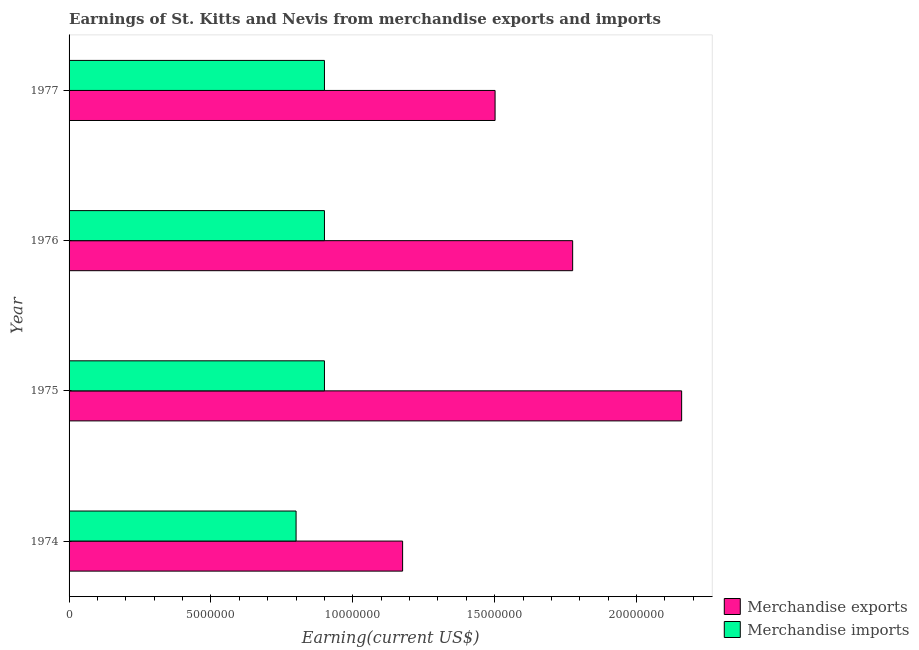How many different coloured bars are there?
Make the answer very short. 2. Are the number of bars per tick equal to the number of legend labels?
Keep it short and to the point. Yes. Are the number of bars on each tick of the Y-axis equal?
Keep it short and to the point. Yes. How many bars are there on the 1st tick from the bottom?
Provide a short and direct response. 2. In how many cases, is the number of bars for a given year not equal to the number of legend labels?
Provide a succinct answer. 0. What is the earnings from merchandise imports in 1975?
Provide a short and direct response. 9.00e+06. Across all years, what is the maximum earnings from merchandise imports?
Make the answer very short. 9.00e+06. Across all years, what is the minimum earnings from merchandise imports?
Your response must be concise. 8.00e+06. In which year was the earnings from merchandise exports maximum?
Provide a succinct answer. 1975. In which year was the earnings from merchandise imports minimum?
Provide a succinct answer. 1974. What is the total earnings from merchandise exports in the graph?
Your answer should be compact. 6.61e+07. What is the difference between the earnings from merchandise imports in 1975 and that in 1977?
Your answer should be compact. 0. What is the difference between the earnings from merchandise imports in 1975 and the earnings from merchandise exports in 1974?
Provide a short and direct response. -2.75e+06. What is the average earnings from merchandise imports per year?
Offer a very short reply. 8.75e+06. In the year 1974, what is the difference between the earnings from merchandise exports and earnings from merchandise imports?
Give a very brief answer. 3.75e+06. What is the ratio of the earnings from merchandise exports in 1974 to that in 1976?
Your answer should be compact. 0.66. Is the earnings from merchandise exports in 1974 less than that in 1976?
Make the answer very short. Yes. Is the difference between the earnings from merchandise exports in 1974 and 1975 greater than the difference between the earnings from merchandise imports in 1974 and 1975?
Your response must be concise. No. What is the difference between the highest and the second highest earnings from merchandise exports?
Provide a succinct answer. 3.84e+06. What is the difference between the highest and the lowest earnings from merchandise exports?
Your response must be concise. 9.83e+06. What does the 1st bar from the bottom in 1975 represents?
Your answer should be very brief. Merchandise exports. How many bars are there?
Ensure brevity in your answer.  8. Are the values on the major ticks of X-axis written in scientific E-notation?
Ensure brevity in your answer.  No. Does the graph contain grids?
Give a very brief answer. No. What is the title of the graph?
Ensure brevity in your answer.  Earnings of St. Kitts and Nevis from merchandise exports and imports. What is the label or title of the X-axis?
Offer a very short reply. Earning(current US$). What is the Earning(current US$) in Merchandise exports in 1974?
Your response must be concise. 1.18e+07. What is the Earning(current US$) of Merchandise exports in 1975?
Provide a short and direct response. 2.16e+07. What is the Earning(current US$) in Merchandise imports in 1975?
Make the answer very short. 9.00e+06. What is the Earning(current US$) in Merchandise exports in 1976?
Provide a short and direct response. 1.77e+07. What is the Earning(current US$) in Merchandise imports in 1976?
Your answer should be compact. 9.00e+06. What is the Earning(current US$) of Merchandise exports in 1977?
Your answer should be compact. 1.50e+07. What is the Earning(current US$) of Merchandise imports in 1977?
Your answer should be very brief. 9.00e+06. Across all years, what is the maximum Earning(current US$) of Merchandise exports?
Keep it short and to the point. 2.16e+07. Across all years, what is the maximum Earning(current US$) of Merchandise imports?
Your response must be concise. 9.00e+06. Across all years, what is the minimum Earning(current US$) in Merchandise exports?
Offer a terse response. 1.18e+07. What is the total Earning(current US$) of Merchandise exports in the graph?
Your answer should be very brief. 6.61e+07. What is the total Earning(current US$) in Merchandise imports in the graph?
Provide a short and direct response. 3.50e+07. What is the difference between the Earning(current US$) of Merchandise exports in 1974 and that in 1975?
Provide a short and direct response. -9.83e+06. What is the difference between the Earning(current US$) in Merchandise exports in 1974 and that in 1976?
Your answer should be compact. -5.99e+06. What is the difference between the Earning(current US$) in Merchandise exports in 1974 and that in 1977?
Make the answer very short. -3.26e+06. What is the difference between the Earning(current US$) of Merchandise imports in 1974 and that in 1977?
Offer a very short reply. -1.00e+06. What is the difference between the Earning(current US$) of Merchandise exports in 1975 and that in 1976?
Your answer should be very brief. 3.84e+06. What is the difference between the Earning(current US$) of Merchandise exports in 1975 and that in 1977?
Your response must be concise. 6.57e+06. What is the difference between the Earning(current US$) in Merchandise imports in 1975 and that in 1977?
Your answer should be compact. 0. What is the difference between the Earning(current US$) of Merchandise exports in 1976 and that in 1977?
Your answer should be compact. 2.73e+06. What is the difference between the Earning(current US$) in Merchandise exports in 1974 and the Earning(current US$) in Merchandise imports in 1975?
Your answer should be compact. 2.75e+06. What is the difference between the Earning(current US$) in Merchandise exports in 1974 and the Earning(current US$) in Merchandise imports in 1976?
Your answer should be very brief. 2.75e+06. What is the difference between the Earning(current US$) in Merchandise exports in 1974 and the Earning(current US$) in Merchandise imports in 1977?
Provide a succinct answer. 2.75e+06. What is the difference between the Earning(current US$) in Merchandise exports in 1975 and the Earning(current US$) in Merchandise imports in 1976?
Offer a terse response. 1.26e+07. What is the difference between the Earning(current US$) in Merchandise exports in 1975 and the Earning(current US$) in Merchandise imports in 1977?
Keep it short and to the point. 1.26e+07. What is the difference between the Earning(current US$) of Merchandise exports in 1976 and the Earning(current US$) of Merchandise imports in 1977?
Your response must be concise. 8.75e+06. What is the average Earning(current US$) of Merchandise exports per year?
Give a very brief answer. 1.65e+07. What is the average Earning(current US$) in Merchandise imports per year?
Your response must be concise. 8.75e+06. In the year 1974, what is the difference between the Earning(current US$) of Merchandise exports and Earning(current US$) of Merchandise imports?
Provide a short and direct response. 3.75e+06. In the year 1975, what is the difference between the Earning(current US$) in Merchandise exports and Earning(current US$) in Merchandise imports?
Provide a succinct answer. 1.26e+07. In the year 1976, what is the difference between the Earning(current US$) of Merchandise exports and Earning(current US$) of Merchandise imports?
Ensure brevity in your answer.  8.75e+06. In the year 1977, what is the difference between the Earning(current US$) of Merchandise exports and Earning(current US$) of Merchandise imports?
Offer a very short reply. 6.01e+06. What is the ratio of the Earning(current US$) in Merchandise exports in 1974 to that in 1975?
Make the answer very short. 0.54. What is the ratio of the Earning(current US$) in Merchandise exports in 1974 to that in 1976?
Make the answer very short. 0.66. What is the ratio of the Earning(current US$) in Merchandise imports in 1974 to that in 1976?
Provide a short and direct response. 0.89. What is the ratio of the Earning(current US$) in Merchandise exports in 1974 to that in 1977?
Keep it short and to the point. 0.78. What is the ratio of the Earning(current US$) of Merchandise imports in 1974 to that in 1977?
Provide a short and direct response. 0.89. What is the ratio of the Earning(current US$) of Merchandise exports in 1975 to that in 1976?
Offer a terse response. 1.22. What is the ratio of the Earning(current US$) of Merchandise imports in 1975 to that in 1976?
Provide a succinct answer. 1. What is the ratio of the Earning(current US$) of Merchandise exports in 1975 to that in 1977?
Give a very brief answer. 1.44. What is the ratio of the Earning(current US$) in Merchandise imports in 1975 to that in 1977?
Ensure brevity in your answer.  1. What is the ratio of the Earning(current US$) of Merchandise exports in 1976 to that in 1977?
Keep it short and to the point. 1.18. What is the difference between the highest and the second highest Earning(current US$) in Merchandise exports?
Keep it short and to the point. 3.84e+06. What is the difference between the highest and the lowest Earning(current US$) of Merchandise exports?
Ensure brevity in your answer.  9.83e+06. 